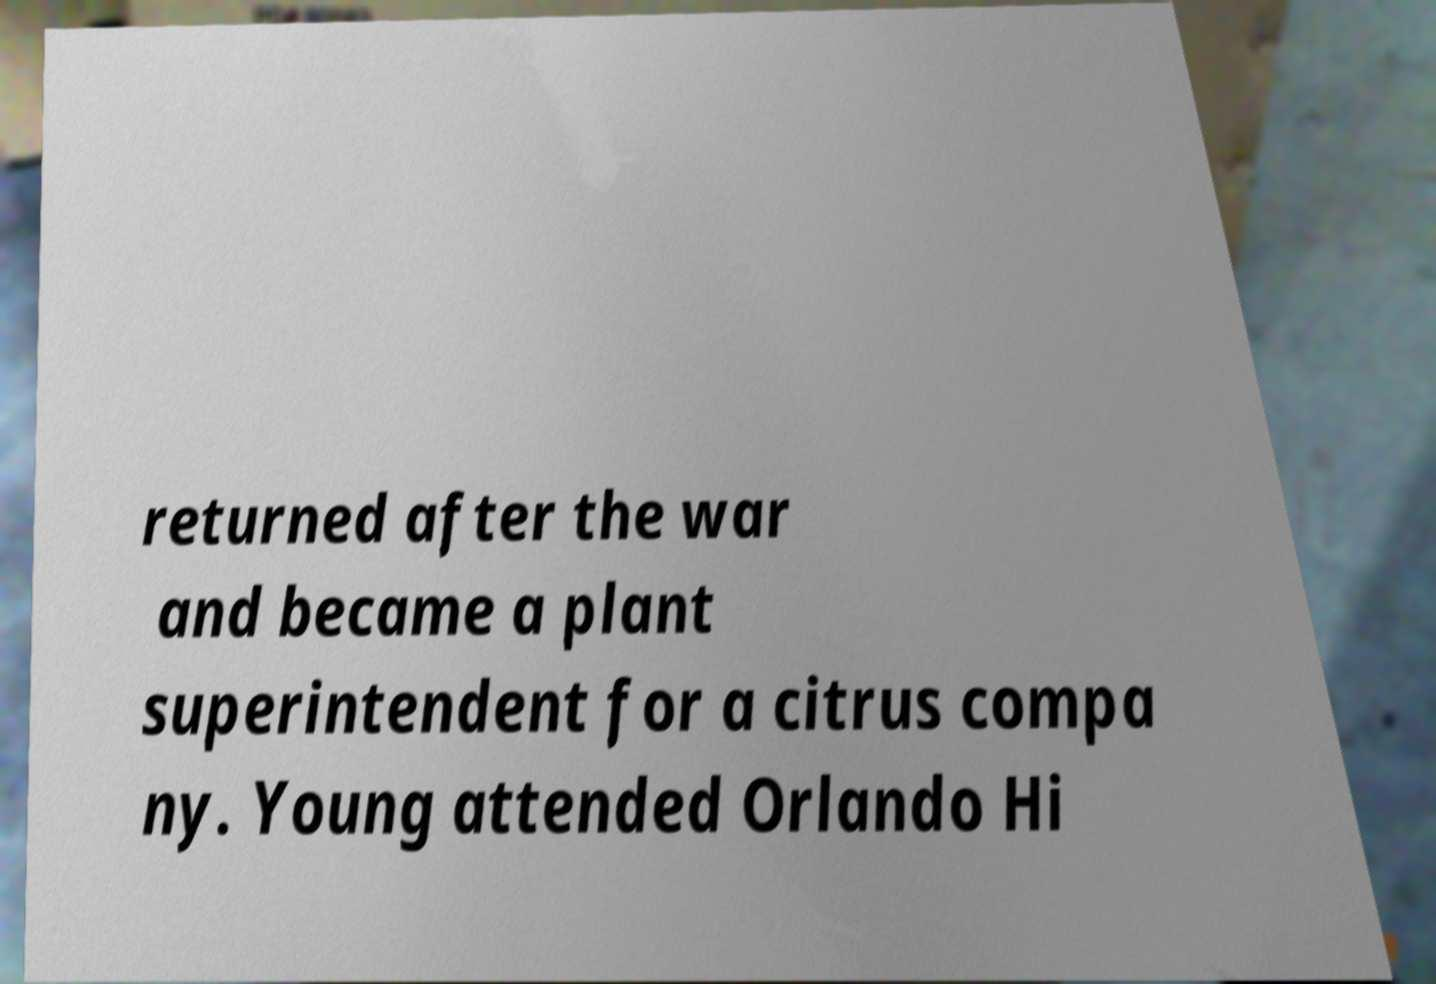Please read and relay the text visible in this image. What does it say? returned after the war and became a plant superintendent for a citrus compa ny. Young attended Orlando Hi 